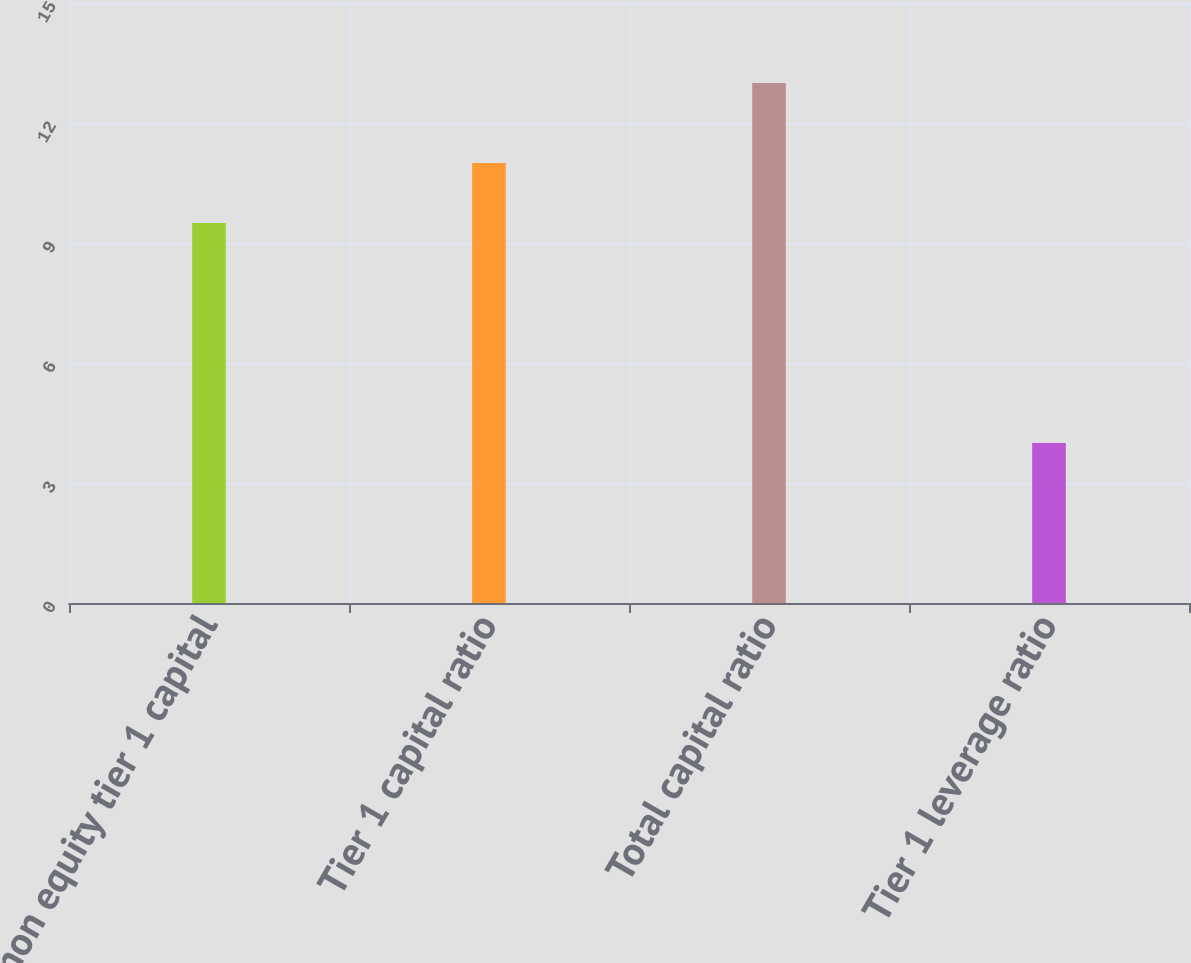Convert chart to OTSL. <chart><loc_0><loc_0><loc_500><loc_500><bar_chart><fcel>Common equity tier 1 capital<fcel>Tier 1 capital ratio<fcel>Total capital ratio<fcel>Tier 1 leverage ratio<nl><fcel>9.5<fcel>11<fcel>13<fcel>4<nl></chart> 